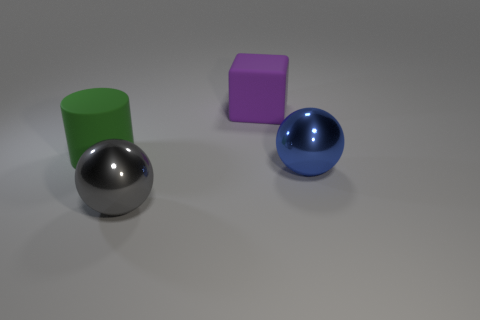Add 3 big cubes. How many objects exist? 7 Subtract all cubes. How many objects are left? 3 Subtract 0 cyan blocks. How many objects are left? 4 Subtract all large rubber cubes. Subtract all cylinders. How many objects are left? 2 Add 4 big metal spheres. How many big metal spheres are left? 6 Add 3 purple rubber objects. How many purple rubber objects exist? 4 